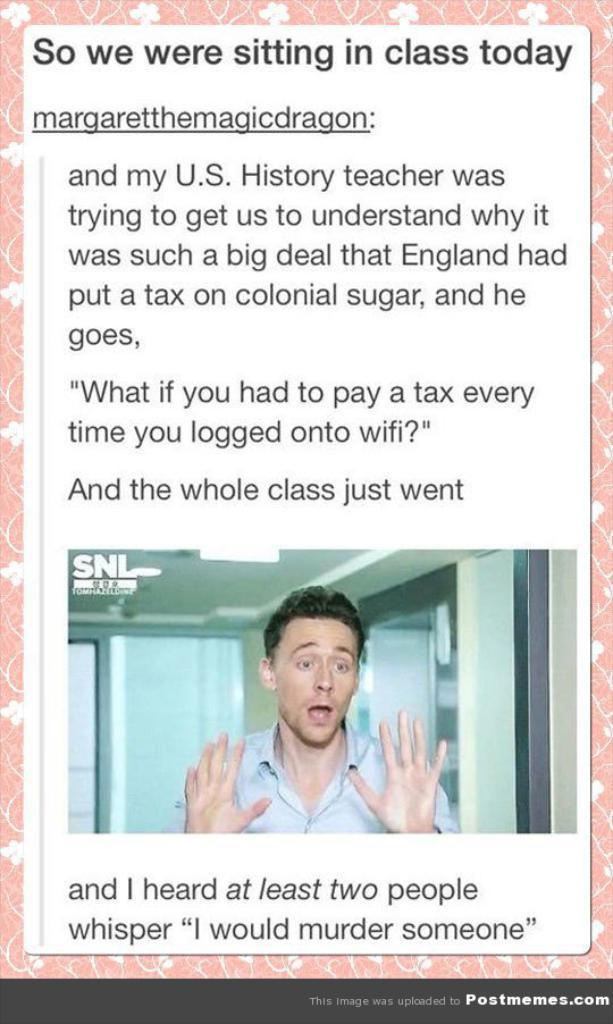How would you summarize this image in a sentence or two? In this image there is a card on a cloth, there is text on the card, there is a man on the card, there are windows, there is the wall, there is a roof, there are lights, there is text towards the bottom of the image. 